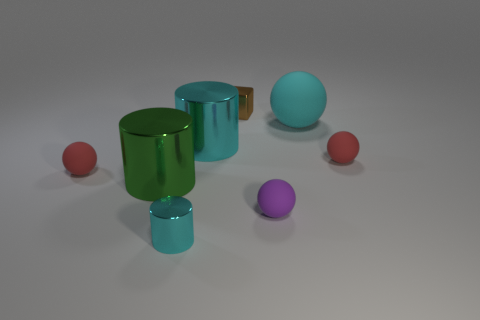There is a small cyan metallic thing; does it have the same shape as the red object to the right of the large matte sphere?
Keep it short and to the point. No. What number of objects are either cyan cylinders that are right of the tiny cyan cylinder or purple rubber objects?
Keep it short and to the point. 2. Is the material of the tiny block the same as the cylinder behind the large green shiny thing?
Offer a very short reply. Yes. There is a big thing in front of the small red rubber ball that is right of the tiny brown object; what is its shape?
Your response must be concise. Cylinder. There is a small metallic cube; does it have the same color as the tiny shiny thing that is to the left of the large cyan cylinder?
Provide a succinct answer. No. Are there any other things that have the same material as the tiny purple ball?
Give a very brief answer. Yes. There is a large cyan rubber thing; what shape is it?
Provide a short and direct response. Sphere. There is a rubber thing that is on the left side of the tiny shiny object on the left side of the brown cube; what size is it?
Make the answer very short. Small. Are there the same number of large metal things behind the brown metal block and big cyan rubber balls that are behind the big cyan rubber object?
Offer a very short reply. Yes. The sphere that is behind the purple matte ball and left of the large cyan matte object is made of what material?
Keep it short and to the point. Rubber. 